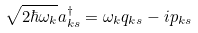<formula> <loc_0><loc_0><loc_500><loc_500>\sqrt { 2 \hbar { \omega } _ { k } } a _ { k s } ^ { \dagger } = \omega _ { k } q _ { k s } - i p _ { k s }</formula> 